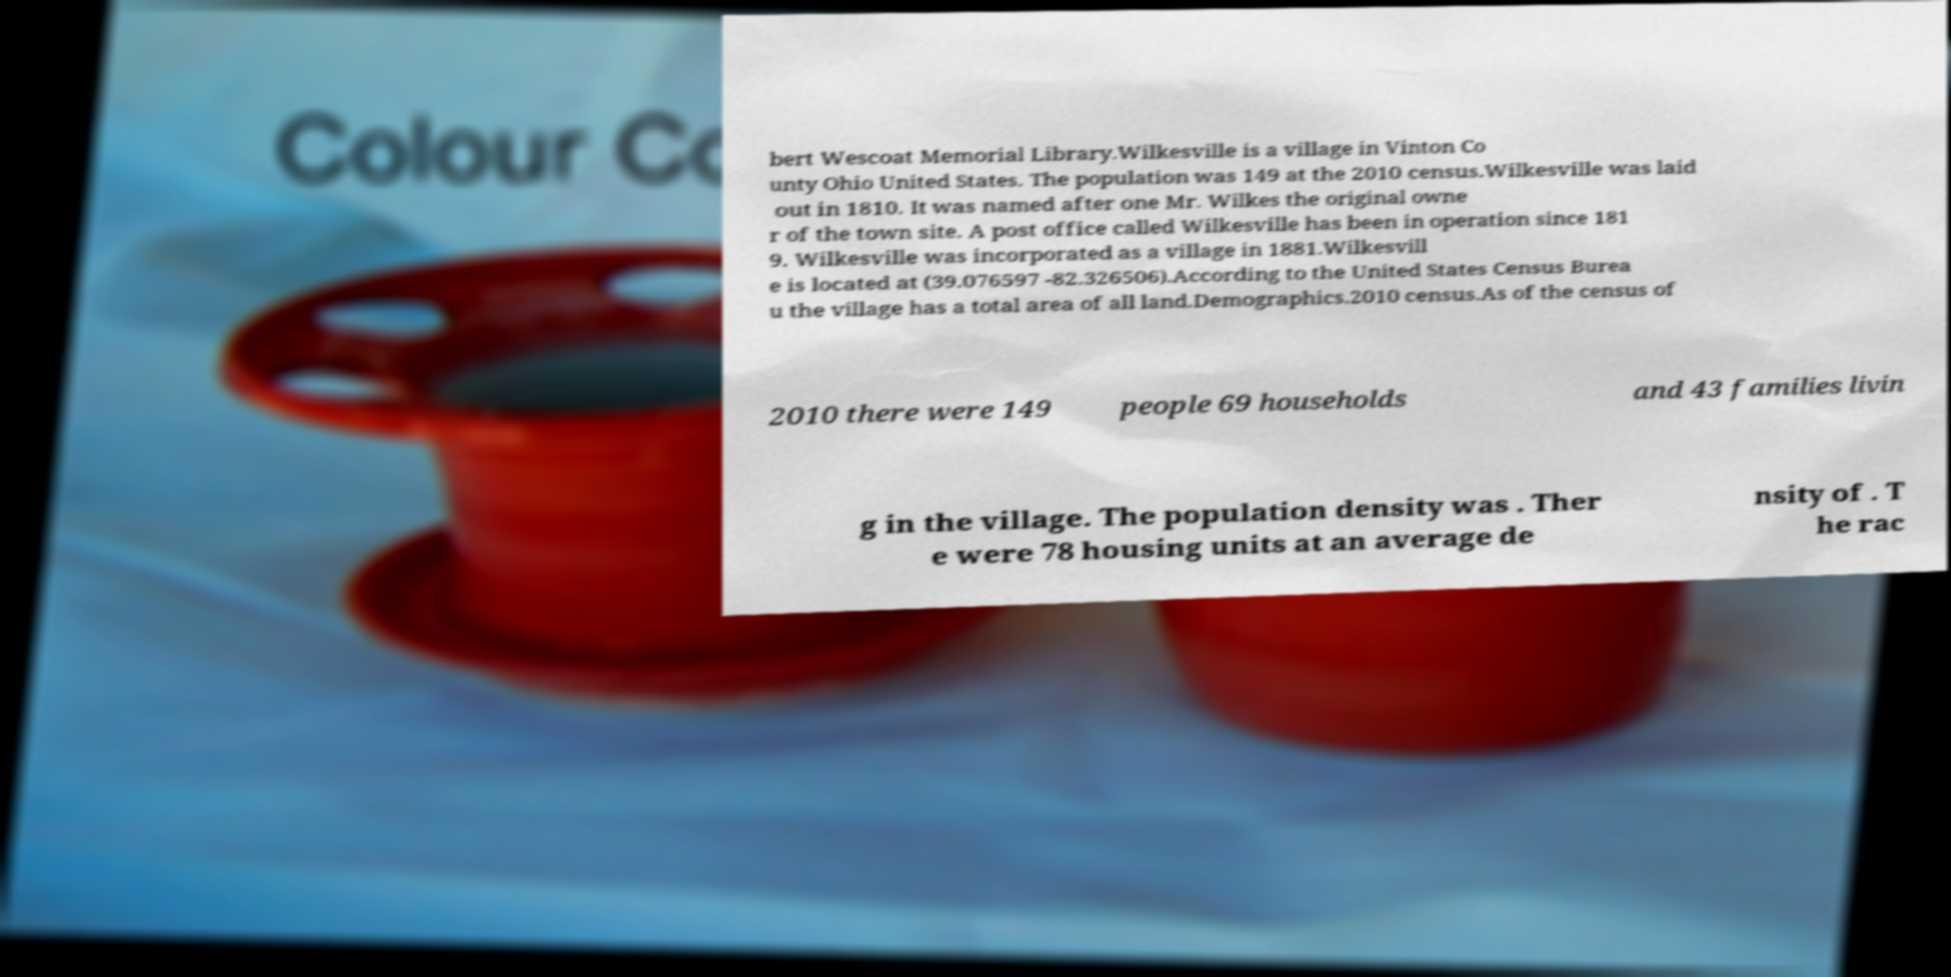Could you assist in decoding the text presented in this image and type it out clearly? bert Wescoat Memorial Library.Wilkesville is a village in Vinton Co unty Ohio United States. The population was 149 at the 2010 census.Wilkesville was laid out in 1810. It was named after one Mr. Wilkes the original owne r of the town site. A post office called Wilkesville has been in operation since 181 9. Wilkesville was incorporated as a village in 1881.Wilkesvill e is located at (39.076597 -82.326506).According to the United States Census Burea u the village has a total area of all land.Demographics.2010 census.As of the census of 2010 there were 149 people 69 households and 43 families livin g in the village. The population density was . Ther e were 78 housing units at an average de nsity of . T he rac 